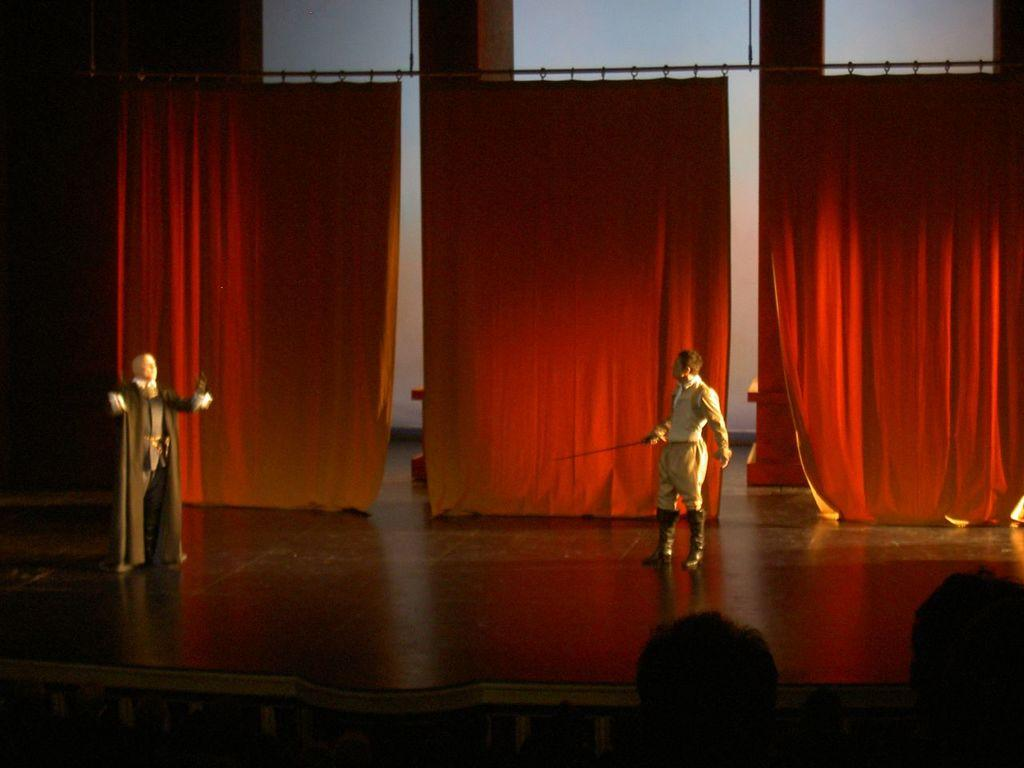What is the main subject of the image? The main subject of the image is a group of people. Can you describe the man in the middle of the image? The man in the middle of the image is holding a sword. What can be seen in the background of the image? There are curtains in the background of the image. What type of punishment is being administered to the pest in the image? There is no pest or punishment present in the image; it features a group of people and a man holding a sword. 